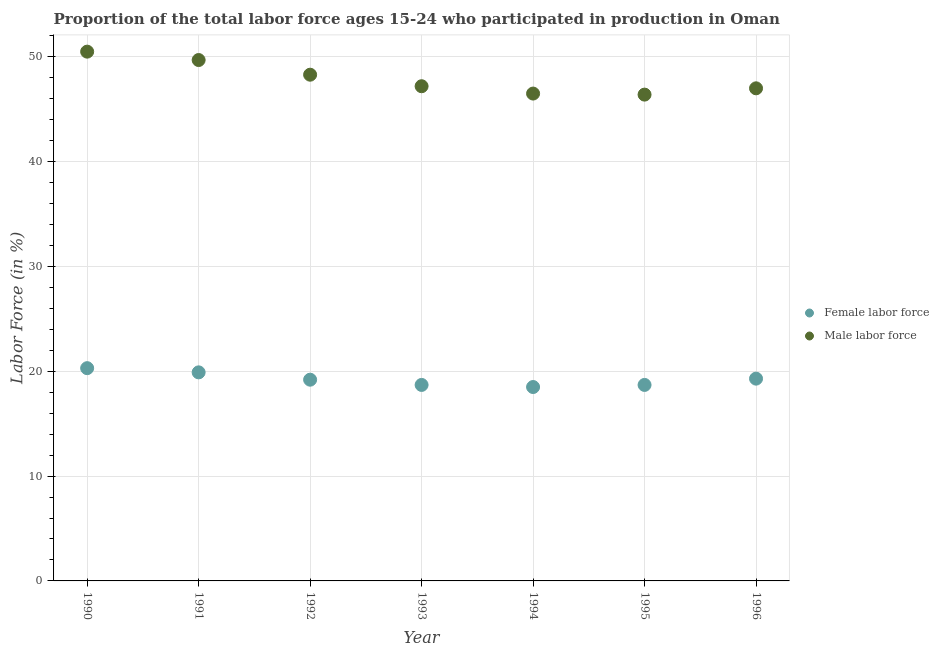How many different coloured dotlines are there?
Keep it short and to the point. 2. Is the number of dotlines equal to the number of legend labels?
Keep it short and to the point. Yes. What is the percentage of male labour force in 1990?
Ensure brevity in your answer.  50.5. Across all years, what is the maximum percentage of female labor force?
Your response must be concise. 20.3. Across all years, what is the minimum percentage of male labour force?
Your answer should be compact. 46.4. In which year was the percentage of female labor force maximum?
Keep it short and to the point. 1990. In which year was the percentage of male labour force minimum?
Provide a succinct answer. 1995. What is the total percentage of male labour force in the graph?
Make the answer very short. 335.6. What is the difference between the percentage of female labor force in 1991 and that in 1996?
Your answer should be very brief. 0.6. What is the difference between the percentage of male labour force in 1991 and the percentage of female labor force in 1992?
Make the answer very short. 30.5. What is the average percentage of male labour force per year?
Offer a very short reply. 47.94. In the year 1993, what is the difference between the percentage of male labour force and percentage of female labor force?
Offer a terse response. 28.5. In how many years, is the percentage of female labor force greater than 4 %?
Provide a short and direct response. 7. What is the ratio of the percentage of female labor force in 1994 to that in 1995?
Give a very brief answer. 0.99. Is the percentage of female labor force in 1991 less than that in 1994?
Keep it short and to the point. No. What is the difference between the highest and the second highest percentage of male labour force?
Keep it short and to the point. 0.8. What is the difference between the highest and the lowest percentage of female labor force?
Offer a terse response. 1.8. In how many years, is the percentage of male labour force greater than the average percentage of male labour force taken over all years?
Offer a very short reply. 3. Is the percentage of male labour force strictly greater than the percentage of female labor force over the years?
Provide a succinct answer. Yes. Is the percentage of male labour force strictly less than the percentage of female labor force over the years?
Provide a short and direct response. No. What is the difference between two consecutive major ticks on the Y-axis?
Make the answer very short. 10. Are the values on the major ticks of Y-axis written in scientific E-notation?
Provide a short and direct response. No. Does the graph contain any zero values?
Ensure brevity in your answer.  No. Where does the legend appear in the graph?
Make the answer very short. Center right. How many legend labels are there?
Offer a terse response. 2. What is the title of the graph?
Make the answer very short. Proportion of the total labor force ages 15-24 who participated in production in Oman. Does "IMF concessional" appear as one of the legend labels in the graph?
Your response must be concise. No. What is the Labor Force (in %) in Female labor force in 1990?
Give a very brief answer. 20.3. What is the Labor Force (in %) in Male labor force in 1990?
Your answer should be compact. 50.5. What is the Labor Force (in %) of Female labor force in 1991?
Provide a short and direct response. 19.9. What is the Labor Force (in %) in Male labor force in 1991?
Give a very brief answer. 49.7. What is the Labor Force (in %) in Female labor force in 1992?
Your answer should be very brief. 19.2. What is the Labor Force (in %) of Male labor force in 1992?
Offer a terse response. 48.3. What is the Labor Force (in %) of Female labor force in 1993?
Give a very brief answer. 18.7. What is the Labor Force (in %) of Male labor force in 1993?
Give a very brief answer. 47.2. What is the Labor Force (in %) of Female labor force in 1994?
Provide a short and direct response. 18.5. What is the Labor Force (in %) in Male labor force in 1994?
Your answer should be compact. 46.5. What is the Labor Force (in %) of Female labor force in 1995?
Keep it short and to the point. 18.7. What is the Labor Force (in %) in Male labor force in 1995?
Offer a very short reply. 46.4. What is the Labor Force (in %) in Female labor force in 1996?
Ensure brevity in your answer.  19.3. What is the Labor Force (in %) of Male labor force in 1996?
Your answer should be very brief. 47. Across all years, what is the maximum Labor Force (in %) of Female labor force?
Your answer should be compact. 20.3. Across all years, what is the maximum Labor Force (in %) in Male labor force?
Offer a terse response. 50.5. Across all years, what is the minimum Labor Force (in %) of Male labor force?
Provide a succinct answer. 46.4. What is the total Labor Force (in %) of Female labor force in the graph?
Offer a terse response. 134.6. What is the total Labor Force (in %) of Male labor force in the graph?
Your answer should be compact. 335.6. What is the difference between the Labor Force (in %) of Female labor force in 1990 and that in 1991?
Provide a short and direct response. 0.4. What is the difference between the Labor Force (in %) in Female labor force in 1990 and that in 1992?
Keep it short and to the point. 1.1. What is the difference between the Labor Force (in %) of Male labor force in 1990 and that in 1992?
Offer a very short reply. 2.2. What is the difference between the Labor Force (in %) of Female labor force in 1990 and that in 1993?
Ensure brevity in your answer.  1.6. What is the difference between the Labor Force (in %) in Male labor force in 1990 and that in 1993?
Your response must be concise. 3.3. What is the difference between the Labor Force (in %) in Male labor force in 1990 and that in 1994?
Give a very brief answer. 4. What is the difference between the Labor Force (in %) of Female labor force in 1990 and that in 1995?
Provide a succinct answer. 1.6. What is the difference between the Labor Force (in %) in Female labor force in 1990 and that in 1996?
Ensure brevity in your answer.  1. What is the difference between the Labor Force (in %) in Male labor force in 1991 and that in 1992?
Your response must be concise. 1.4. What is the difference between the Labor Force (in %) of Female labor force in 1991 and that in 1994?
Your response must be concise. 1.4. What is the difference between the Labor Force (in %) in Male labor force in 1991 and that in 1995?
Provide a short and direct response. 3.3. What is the difference between the Labor Force (in %) in Female labor force in 1992 and that in 1993?
Your response must be concise. 0.5. What is the difference between the Labor Force (in %) in Female labor force in 1992 and that in 1994?
Offer a very short reply. 0.7. What is the difference between the Labor Force (in %) of Male labor force in 1992 and that in 1994?
Give a very brief answer. 1.8. What is the difference between the Labor Force (in %) in Female labor force in 1992 and that in 1995?
Your response must be concise. 0.5. What is the difference between the Labor Force (in %) of Female labor force in 1993 and that in 1994?
Keep it short and to the point. 0.2. What is the difference between the Labor Force (in %) of Male labor force in 1993 and that in 1994?
Make the answer very short. 0.7. What is the difference between the Labor Force (in %) of Female labor force in 1993 and that in 1995?
Your answer should be compact. 0. What is the difference between the Labor Force (in %) in Male labor force in 1993 and that in 1995?
Your response must be concise. 0.8. What is the difference between the Labor Force (in %) of Female labor force in 1993 and that in 1996?
Keep it short and to the point. -0.6. What is the difference between the Labor Force (in %) of Female labor force in 1994 and that in 1995?
Keep it short and to the point. -0.2. What is the difference between the Labor Force (in %) in Female labor force in 1994 and that in 1996?
Your response must be concise. -0.8. What is the difference between the Labor Force (in %) of Male labor force in 1995 and that in 1996?
Make the answer very short. -0.6. What is the difference between the Labor Force (in %) of Female labor force in 1990 and the Labor Force (in %) of Male labor force in 1991?
Offer a very short reply. -29.4. What is the difference between the Labor Force (in %) of Female labor force in 1990 and the Labor Force (in %) of Male labor force in 1992?
Offer a terse response. -28. What is the difference between the Labor Force (in %) of Female labor force in 1990 and the Labor Force (in %) of Male labor force in 1993?
Ensure brevity in your answer.  -26.9. What is the difference between the Labor Force (in %) in Female labor force in 1990 and the Labor Force (in %) in Male labor force in 1994?
Provide a short and direct response. -26.2. What is the difference between the Labor Force (in %) in Female labor force in 1990 and the Labor Force (in %) in Male labor force in 1995?
Your response must be concise. -26.1. What is the difference between the Labor Force (in %) of Female labor force in 1990 and the Labor Force (in %) of Male labor force in 1996?
Your answer should be very brief. -26.7. What is the difference between the Labor Force (in %) of Female labor force in 1991 and the Labor Force (in %) of Male labor force in 1992?
Make the answer very short. -28.4. What is the difference between the Labor Force (in %) in Female labor force in 1991 and the Labor Force (in %) in Male labor force in 1993?
Your answer should be very brief. -27.3. What is the difference between the Labor Force (in %) in Female labor force in 1991 and the Labor Force (in %) in Male labor force in 1994?
Offer a very short reply. -26.6. What is the difference between the Labor Force (in %) in Female labor force in 1991 and the Labor Force (in %) in Male labor force in 1995?
Provide a succinct answer. -26.5. What is the difference between the Labor Force (in %) in Female labor force in 1991 and the Labor Force (in %) in Male labor force in 1996?
Provide a short and direct response. -27.1. What is the difference between the Labor Force (in %) of Female labor force in 1992 and the Labor Force (in %) of Male labor force in 1993?
Offer a very short reply. -28. What is the difference between the Labor Force (in %) of Female labor force in 1992 and the Labor Force (in %) of Male labor force in 1994?
Give a very brief answer. -27.3. What is the difference between the Labor Force (in %) in Female labor force in 1992 and the Labor Force (in %) in Male labor force in 1995?
Ensure brevity in your answer.  -27.2. What is the difference between the Labor Force (in %) in Female labor force in 1992 and the Labor Force (in %) in Male labor force in 1996?
Ensure brevity in your answer.  -27.8. What is the difference between the Labor Force (in %) of Female labor force in 1993 and the Labor Force (in %) of Male labor force in 1994?
Provide a succinct answer. -27.8. What is the difference between the Labor Force (in %) of Female labor force in 1993 and the Labor Force (in %) of Male labor force in 1995?
Provide a succinct answer. -27.7. What is the difference between the Labor Force (in %) of Female labor force in 1993 and the Labor Force (in %) of Male labor force in 1996?
Give a very brief answer. -28.3. What is the difference between the Labor Force (in %) of Female labor force in 1994 and the Labor Force (in %) of Male labor force in 1995?
Your answer should be compact. -27.9. What is the difference between the Labor Force (in %) of Female labor force in 1994 and the Labor Force (in %) of Male labor force in 1996?
Offer a terse response. -28.5. What is the difference between the Labor Force (in %) of Female labor force in 1995 and the Labor Force (in %) of Male labor force in 1996?
Give a very brief answer. -28.3. What is the average Labor Force (in %) of Female labor force per year?
Ensure brevity in your answer.  19.23. What is the average Labor Force (in %) in Male labor force per year?
Give a very brief answer. 47.94. In the year 1990, what is the difference between the Labor Force (in %) in Female labor force and Labor Force (in %) in Male labor force?
Your answer should be very brief. -30.2. In the year 1991, what is the difference between the Labor Force (in %) in Female labor force and Labor Force (in %) in Male labor force?
Offer a terse response. -29.8. In the year 1992, what is the difference between the Labor Force (in %) of Female labor force and Labor Force (in %) of Male labor force?
Ensure brevity in your answer.  -29.1. In the year 1993, what is the difference between the Labor Force (in %) of Female labor force and Labor Force (in %) of Male labor force?
Your answer should be compact. -28.5. In the year 1995, what is the difference between the Labor Force (in %) in Female labor force and Labor Force (in %) in Male labor force?
Keep it short and to the point. -27.7. In the year 1996, what is the difference between the Labor Force (in %) of Female labor force and Labor Force (in %) of Male labor force?
Your answer should be compact. -27.7. What is the ratio of the Labor Force (in %) in Female labor force in 1990 to that in 1991?
Ensure brevity in your answer.  1.02. What is the ratio of the Labor Force (in %) of Male labor force in 1990 to that in 1991?
Your answer should be very brief. 1.02. What is the ratio of the Labor Force (in %) in Female labor force in 1990 to that in 1992?
Your response must be concise. 1.06. What is the ratio of the Labor Force (in %) of Male labor force in 1990 to that in 1992?
Keep it short and to the point. 1.05. What is the ratio of the Labor Force (in %) of Female labor force in 1990 to that in 1993?
Your answer should be compact. 1.09. What is the ratio of the Labor Force (in %) in Male labor force in 1990 to that in 1993?
Your answer should be compact. 1.07. What is the ratio of the Labor Force (in %) in Female labor force in 1990 to that in 1994?
Your answer should be very brief. 1.1. What is the ratio of the Labor Force (in %) of Male labor force in 1990 to that in 1994?
Your answer should be compact. 1.09. What is the ratio of the Labor Force (in %) in Female labor force in 1990 to that in 1995?
Keep it short and to the point. 1.09. What is the ratio of the Labor Force (in %) of Male labor force in 1990 to that in 1995?
Offer a very short reply. 1.09. What is the ratio of the Labor Force (in %) of Female labor force in 1990 to that in 1996?
Keep it short and to the point. 1.05. What is the ratio of the Labor Force (in %) in Male labor force in 1990 to that in 1996?
Your response must be concise. 1.07. What is the ratio of the Labor Force (in %) in Female labor force in 1991 to that in 1992?
Provide a succinct answer. 1.04. What is the ratio of the Labor Force (in %) in Male labor force in 1991 to that in 1992?
Offer a very short reply. 1.03. What is the ratio of the Labor Force (in %) of Female labor force in 1991 to that in 1993?
Make the answer very short. 1.06. What is the ratio of the Labor Force (in %) of Male labor force in 1991 to that in 1993?
Offer a very short reply. 1.05. What is the ratio of the Labor Force (in %) of Female labor force in 1991 to that in 1994?
Keep it short and to the point. 1.08. What is the ratio of the Labor Force (in %) in Male labor force in 1991 to that in 1994?
Provide a short and direct response. 1.07. What is the ratio of the Labor Force (in %) in Female labor force in 1991 to that in 1995?
Your response must be concise. 1.06. What is the ratio of the Labor Force (in %) of Male labor force in 1991 to that in 1995?
Your answer should be very brief. 1.07. What is the ratio of the Labor Force (in %) of Female labor force in 1991 to that in 1996?
Ensure brevity in your answer.  1.03. What is the ratio of the Labor Force (in %) in Male labor force in 1991 to that in 1996?
Offer a very short reply. 1.06. What is the ratio of the Labor Force (in %) in Female labor force in 1992 to that in 1993?
Keep it short and to the point. 1.03. What is the ratio of the Labor Force (in %) in Male labor force in 1992 to that in 1993?
Offer a very short reply. 1.02. What is the ratio of the Labor Force (in %) of Female labor force in 1992 to that in 1994?
Make the answer very short. 1.04. What is the ratio of the Labor Force (in %) of Male labor force in 1992 to that in 1994?
Your answer should be compact. 1.04. What is the ratio of the Labor Force (in %) in Female labor force in 1992 to that in 1995?
Your response must be concise. 1.03. What is the ratio of the Labor Force (in %) in Male labor force in 1992 to that in 1995?
Your answer should be very brief. 1.04. What is the ratio of the Labor Force (in %) of Female labor force in 1992 to that in 1996?
Make the answer very short. 0.99. What is the ratio of the Labor Force (in %) of Male labor force in 1992 to that in 1996?
Give a very brief answer. 1.03. What is the ratio of the Labor Force (in %) of Female labor force in 1993 to that in 1994?
Your answer should be very brief. 1.01. What is the ratio of the Labor Force (in %) in Male labor force in 1993 to that in 1994?
Provide a succinct answer. 1.02. What is the ratio of the Labor Force (in %) in Female labor force in 1993 to that in 1995?
Provide a succinct answer. 1. What is the ratio of the Labor Force (in %) of Male labor force in 1993 to that in 1995?
Provide a short and direct response. 1.02. What is the ratio of the Labor Force (in %) in Female labor force in 1993 to that in 1996?
Make the answer very short. 0.97. What is the ratio of the Labor Force (in %) of Female labor force in 1994 to that in 1995?
Offer a very short reply. 0.99. What is the ratio of the Labor Force (in %) in Female labor force in 1994 to that in 1996?
Provide a succinct answer. 0.96. What is the ratio of the Labor Force (in %) in Male labor force in 1994 to that in 1996?
Ensure brevity in your answer.  0.99. What is the ratio of the Labor Force (in %) of Female labor force in 1995 to that in 1996?
Provide a short and direct response. 0.97. What is the ratio of the Labor Force (in %) of Male labor force in 1995 to that in 1996?
Provide a succinct answer. 0.99. What is the difference between the highest and the second highest Labor Force (in %) of Male labor force?
Give a very brief answer. 0.8. What is the difference between the highest and the lowest Labor Force (in %) in Female labor force?
Provide a succinct answer. 1.8. 